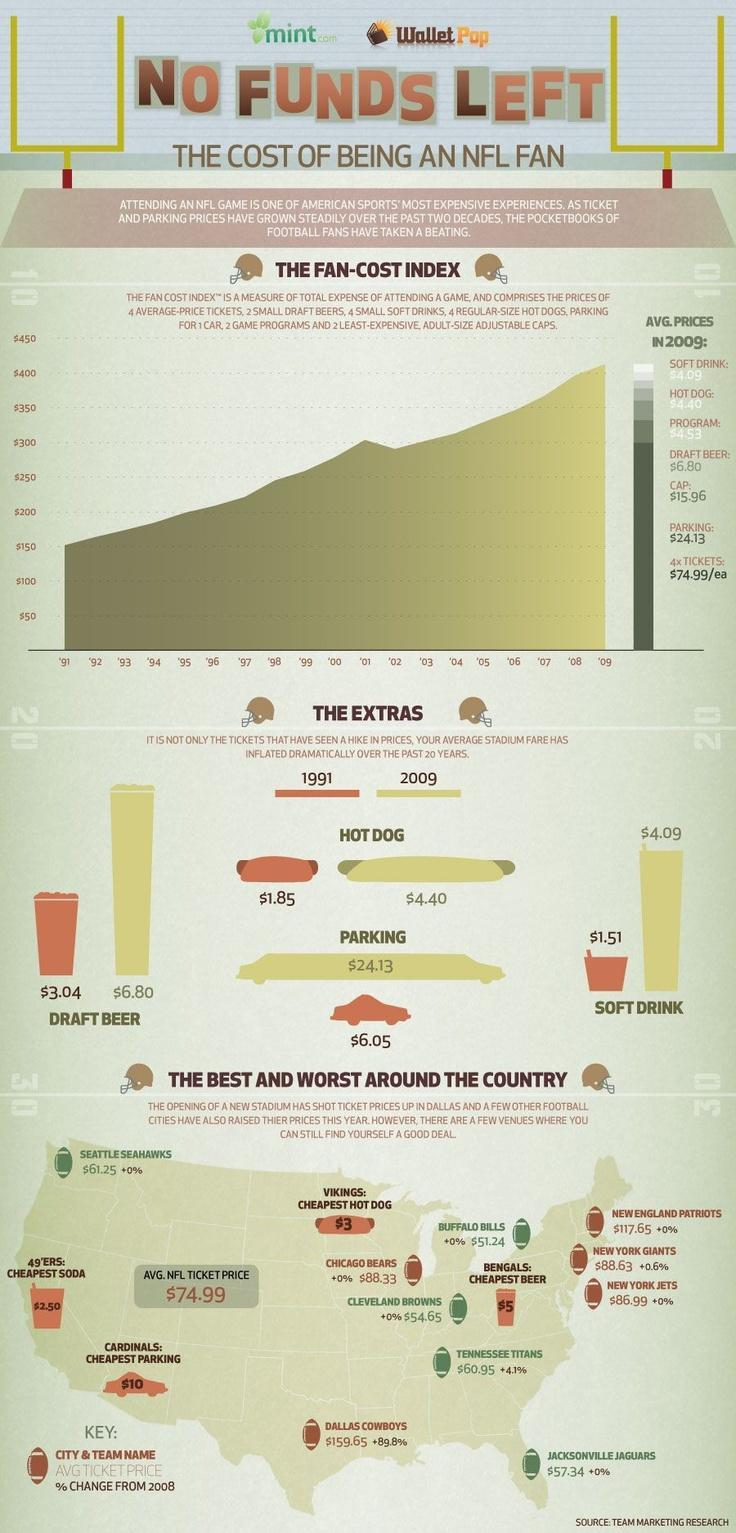What is the average price of a soft drink and hot dog , taken together?
Answer the question with a short phrase. $8.49 What is the difference between the price of Draft Beer in 2009 and 1991? $3.76 What is the difference between the price of Soft Drink in 2009 and 1991? $2.58 What is the difference between the price of Hot Dog in 2009 and 1991? $2.55 What is the average price of a program and draft beer , taken together? $11.33 What is the difference between the price of parking in 2009 and 1991? $18.08 What is the average price of a cap and parking, taken together? $40.09 